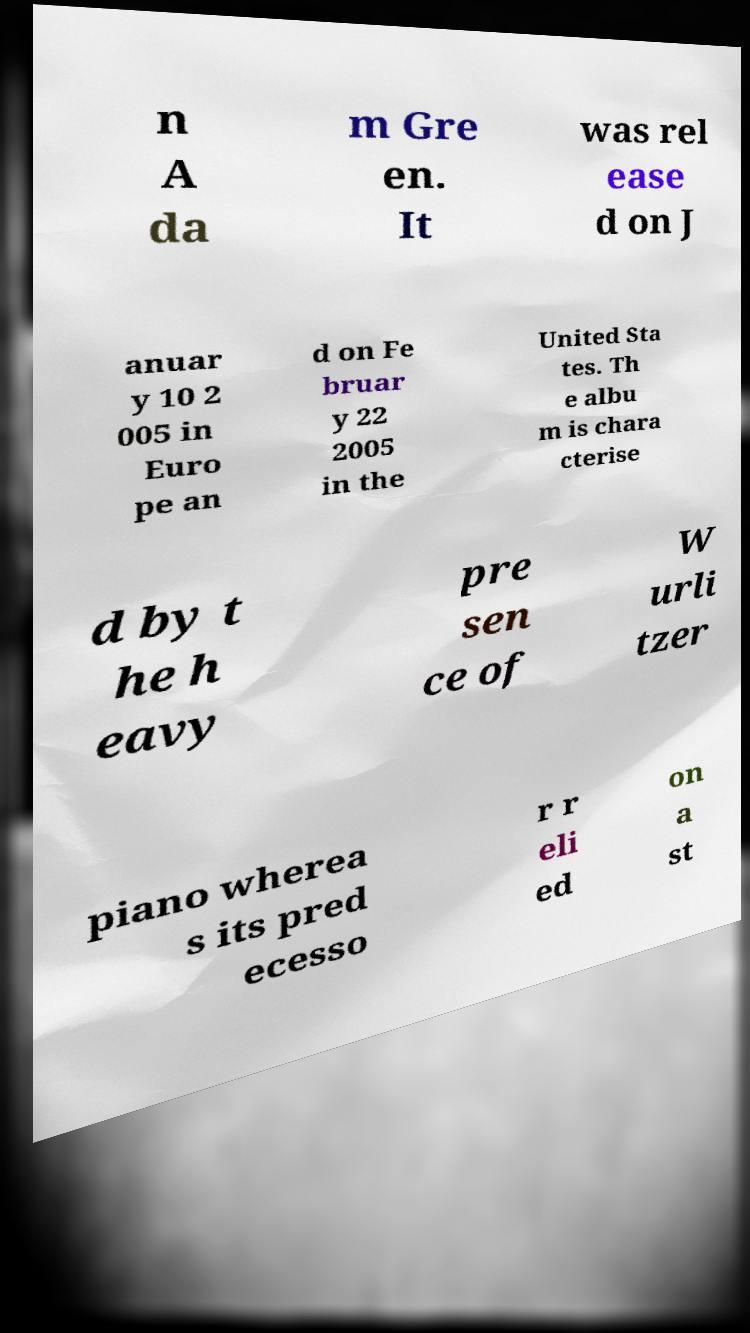Can you read and provide the text displayed in the image?This photo seems to have some interesting text. Can you extract and type it out for me? n A da m Gre en. It was rel ease d on J anuar y 10 2 005 in Euro pe an d on Fe bruar y 22 2005 in the United Sta tes. Th e albu m is chara cterise d by t he h eavy pre sen ce of W urli tzer piano wherea s its pred ecesso r r eli ed on a st 